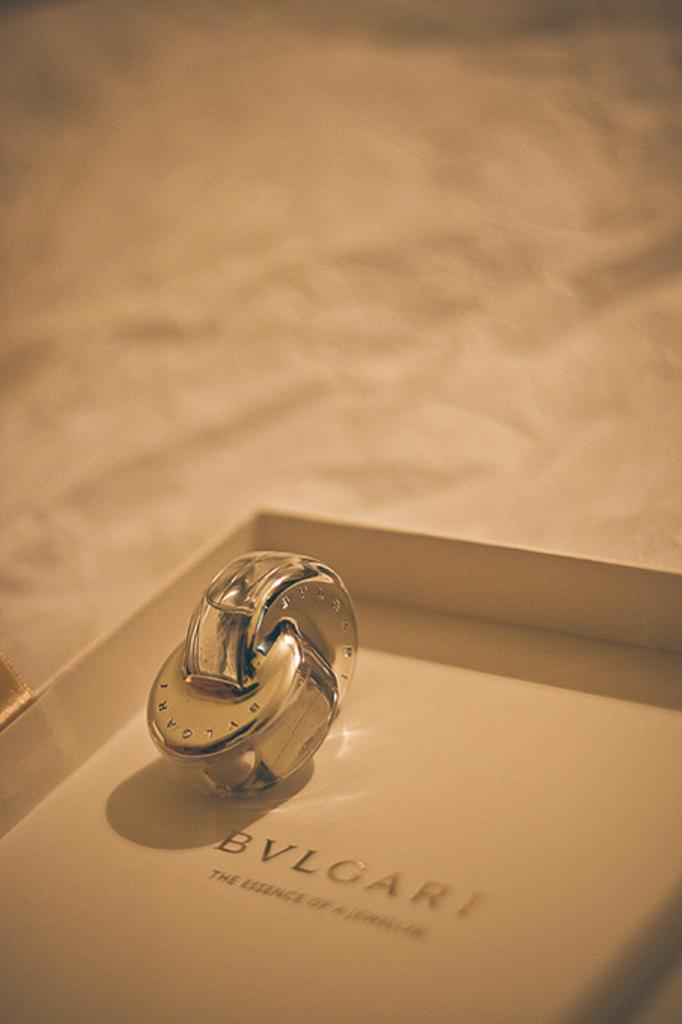What type of object is in the image? There is a metal object in the image. Where is the metal object located? The metal object is in a box. What can be found on the box? The box has text on it. How would you describe the background of the image? The background of the image is blurry. What type of glue is being used to hold the metal object in place in the image? There is no glue present in the image, and the metal object is in a box, not attached to anything. 